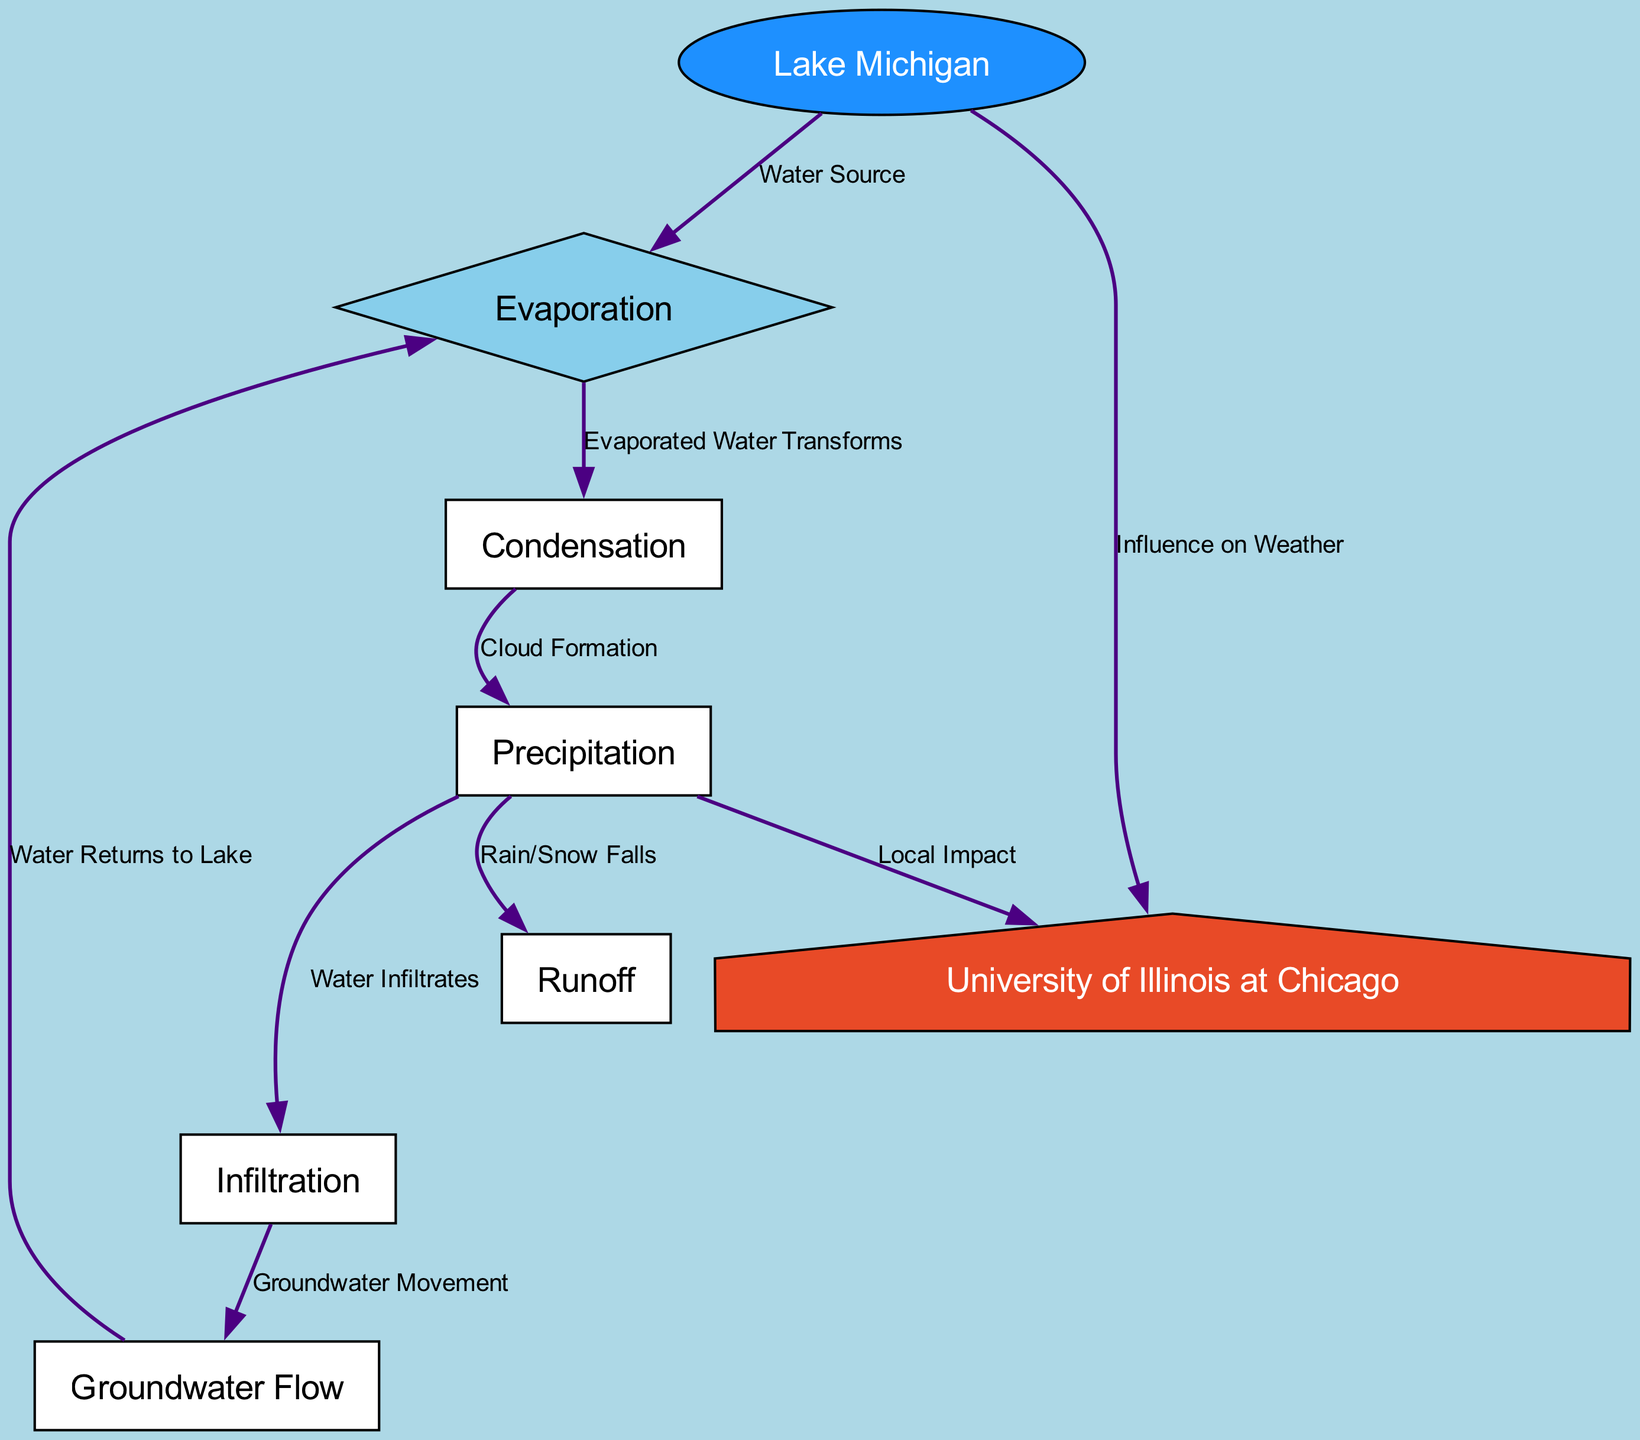What's the total number of nodes in the diagram? The diagram displays six nodes: evaporation, condensation, precipitation, runoff, infiltration, groundwater flow, and UIC. Counting these will determine the total number of nodes.
Answer: 7 What is the first process in the water cycle illustrated? The water cycle begins with evaporation, where water from Lake Michigan vaporizes into the atmosphere. This is the first step represented in the diagram.
Answer: Evaporation How many edges connect UIC to the other processes? By examining the edges, UIC is connected by two edges: one from Lake Michigan and one from precipitation. Thus, counting these connections gives the answer.
Answer: 2 What process follows precipitation in the water cycle? Following precipitation in the diagram, the next steps shown are runoff and infiltration. This indicates the processes occurring directly after precipitation.
Answer: Runoff and infiltration Which node represents the source of water in this cycle? The diagram indicates that Lake Michigan serves as the water source for evaporation, making this node vital for the cycle.
Answer: Lake Michigan What is the relationship between evaporation and condensation? The diagram shows a directed edge labeled "Evaporated Water Transforms," indicating that evaporation directly leads to condensation in the cycle.
Answer: Evaporated Water Transforms Identify the process that involves water flowing over land into Lake Michigan. The runoff process describes how water traverses over the ground and eventually flows into Lake Michigan, as visualized in the diagram.
Answer: Runoff How does groundwater flow relate back to evaporation? The diagram illustrates that groundwater flow returns to Lake Michigan, which then leads back to the evaporation process, completing a circuit in the water cycle.
Answer: Water Returns to Lake What influences local weather patterns as shown in the diagram? The diagram depicts Lake Michigan influencing the weather patterns in Chicago, highlighting this connection as significant to local climate.
Answer: Lake Michigan 